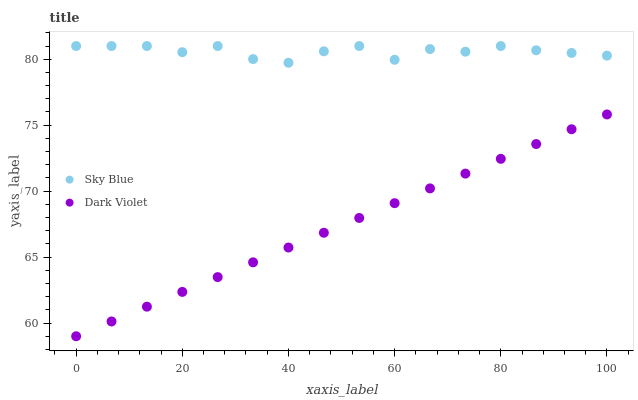Does Dark Violet have the minimum area under the curve?
Answer yes or no. Yes. Does Sky Blue have the maximum area under the curve?
Answer yes or no. Yes. Does Dark Violet have the maximum area under the curve?
Answer yes or no. No. Is Dark Violet the smoothest?
Answer yes or no. Yes. Is Sky Blue the roughest?
Answer yes or no. Yes. Is Dark Violet the roughest?
Answer yes or no. No. Does Dark Violet have the lowest value?
Answer yes or no. Yes. Does Sky Blue have the highest value?
Answer yes or no. Yes. Does Dark Violet have the highest value?
Answer yes or no. No. Is Dark Violet less than Sky Blue?
Answer yes or no. Yes. Is Sky Blue greater than Dark Violet?
Answer yes or no. Yes. Does Dark Violet intersect Sky Blue?
Answer yes or no. No. 